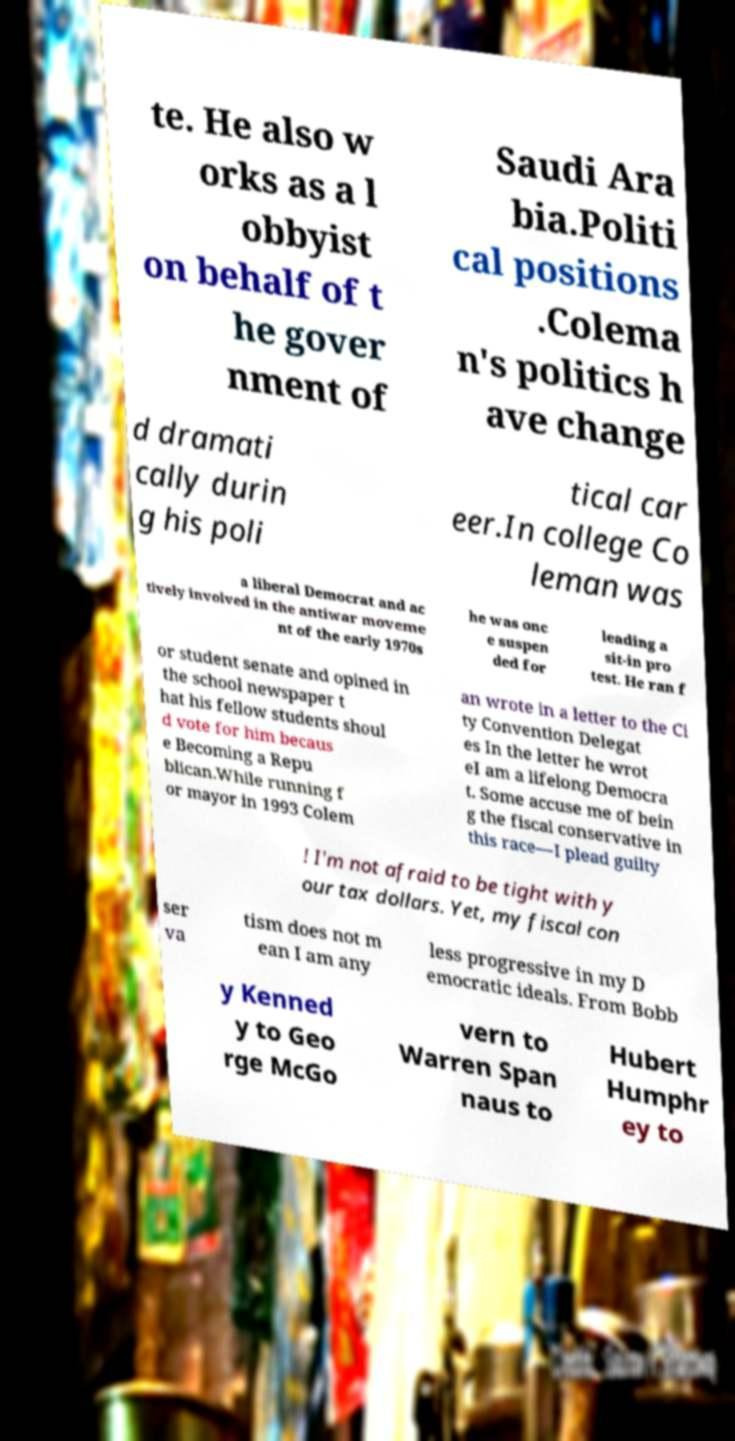Please read and relay the text visible in this image. What does it say? te. He also w orks as a l obbyist on behalf of t he gover nment of Saudi Ara bia.Politi cal positions .Colema n's politics h ave change d dramati cally durin g his poli tical car eer.In college Co leman was a liberal Democrat and ac tively involved in the antiwar moveme nt of the early 1970s he was onc e suspen ded for leading a sit-in pro test. He ran f or student senate and opined in the school newspaper t hat his fellow students shoul d vote for him becaus e Becoming a Repu blican.While running f or mayor in 1993 Colem an wrote in a letter to the Ci ty Convention Delegat es In the letter he wrot eI am a lifelong Democra t. Some accuse me of bein g the fiscal conservative in this race—I plead guilty ! I'm not afraid to be tight with y our tax dollars. Yet, my fiscal con ser va tism does not m ean I am any less progressive in my D emocratic ideals. From Bobb y Kenned y to Geo rge McGo vern to Warren Span naus to Hubert Humphr ey to 